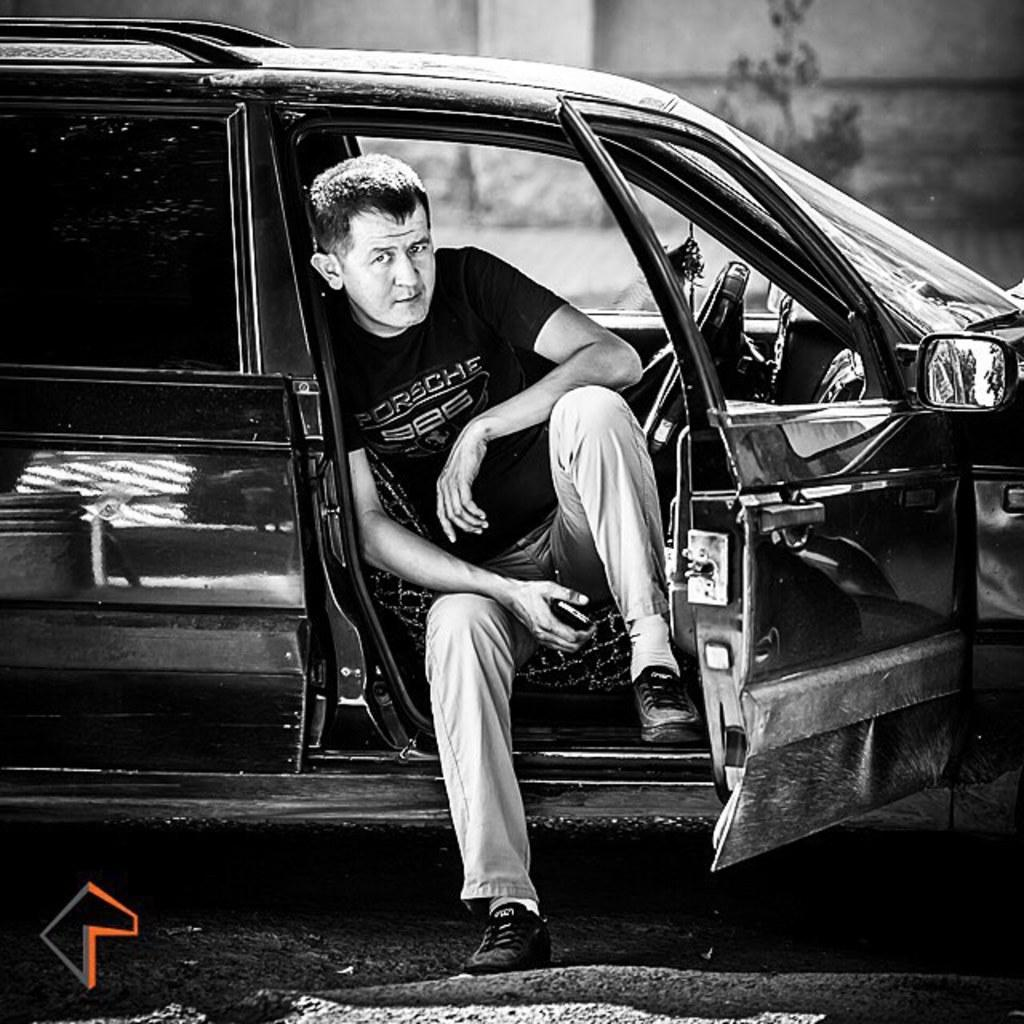What is the person in the image doing? The person is sitting in a car. What can be seen behind the person? There is a wall visible behind the person. What type of shoe is the person wearing in the image? There is no information about the person's shoes in the image, so we cannot determine what type of shoe they are wearing. 